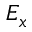Convert formula to latex. <formula><loc_0><loc_0><loc_500><loc_500>E _ { x }</formula> 